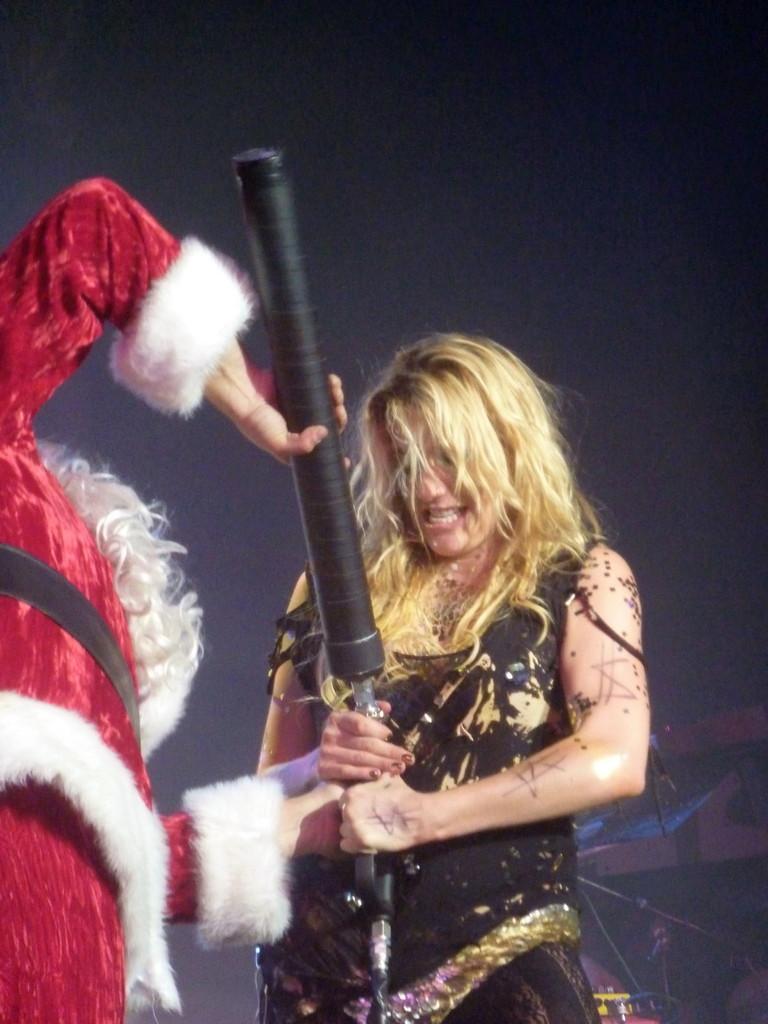In one or two sentences, can you explain what this image depicts? 2 people are standing holding a black tube. The person at the center is wearing a black dress and has blonde hair. The person at the left is wearing santa claus dress. There is a dark background. 